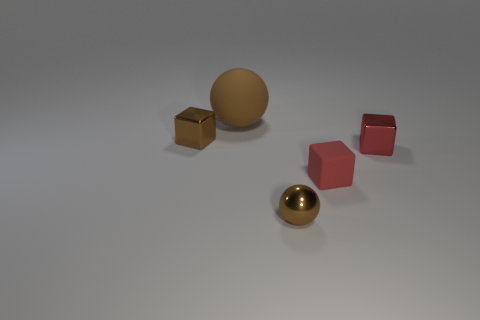What number of brown objects are either rubber spheres or metal blocks?
Keep it short and to the point. 2. Are there fewer big brown matte balls that are behind the large matte sphere than tiny red objects behind the tiny matte block?
Your answer should be compact. Yes. Is there a red matte block that has the same size as the rubber sphere?
Provide a short and direct response. No. There is a brown metallic thing behind the shiny sphere; is it the same size as the small matte thing?
Keep it short and to the point. Yes. Are there more red cubes than small cubes?
Your answer should be very brief. No. Is there a red metallic object that has the same shape as the big brown matte thing?
Your answer should be compact. No. There is a matte object behind the brown shiny block; what shape is it?
Ensure brevity in your answer.  Sphere. What number of metal things are to the left of the tiny red rubber object that is behind the brown ball that is in front of the small brown block?
Your answer should be compact. 2. There is a sphere on the right side of the matte ball; is its color the same as the big rubber object?
Provide a short and direct response. Yes. How many other things are the same shape as the red shiny thing?
Make the answer very short. 2. 